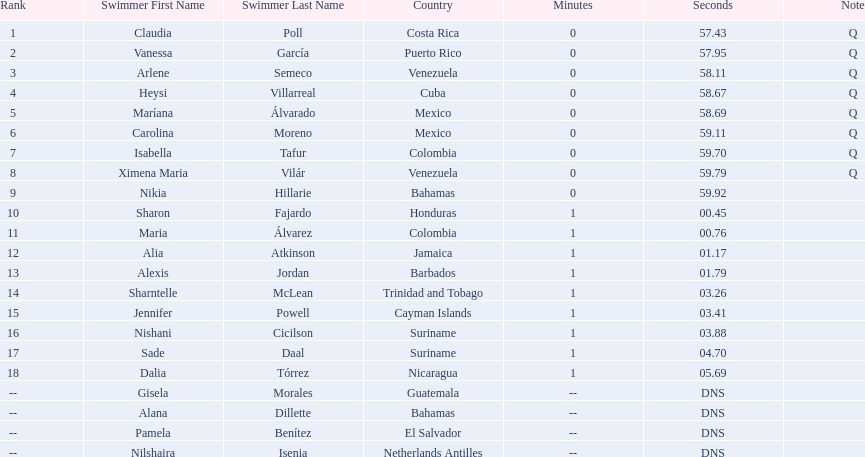Where were the top eight finishers from? Costa Rica, Puerto Rico, Venezuela, Cuba, Mexico, Mexico, Colombia, Venezuela. Which of the top eight were from cuba? Heysi Villarreal. 